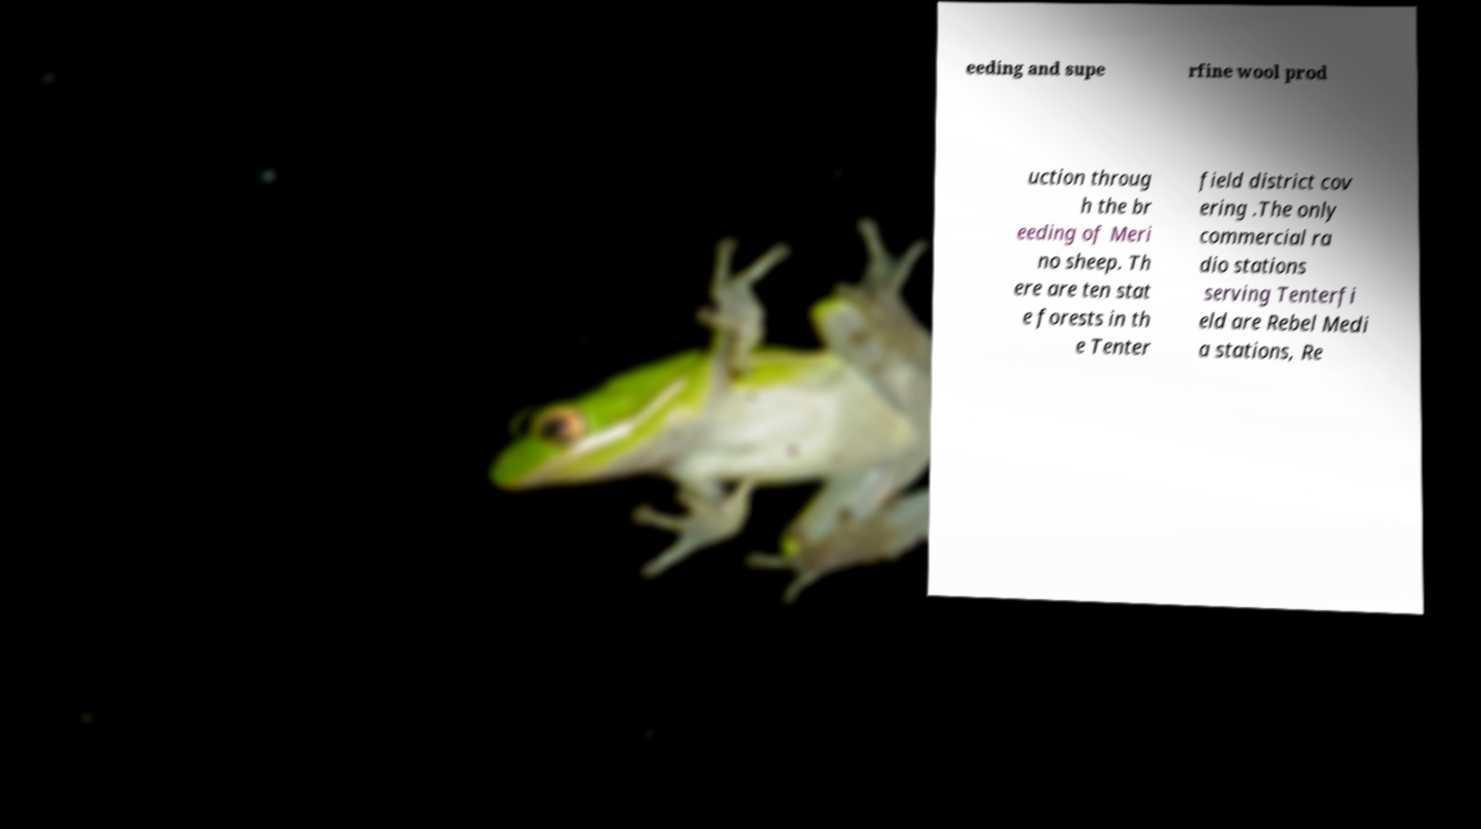Could you assist in decoding the text presented in this image and type it out clearly? eeding and supe rfine wool prod uction throug h the br eeding of Meri no sheep. Th ere are ten stat e forests in th e Tenter field district cov ering .The only commercial ra dio stations serving Tenterfi eld are Rebel Medi a stations, Re 